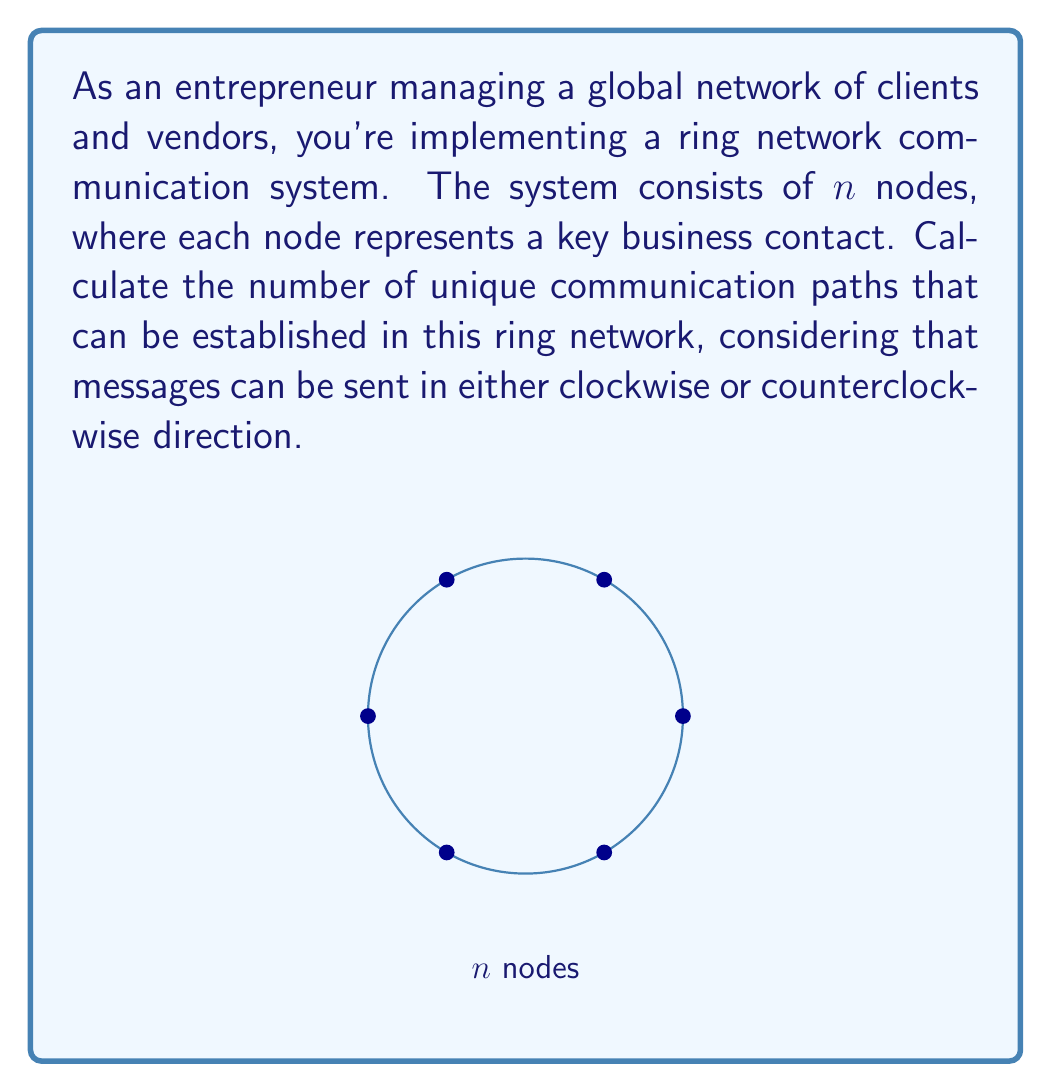Could you help me with this problem? Let's approach this step-by-step:

1) In a ring network with $n$ nodes, each node can communicate with any other node in two ways: clockwise or counterclockwise.

2) For any pair of nodes, there are two unique paths:
   - Clockwise from node A to node B
   - Counterclockwise from node A to node B

3) To count the total number of unique paths, we need to consider all possible pairs of nodes.

4) The total number of pairs in a network with $n$ nodes is given by the combination formula:

   $$\binom{n}{2} = \frac{n!}{2!(n-2)!} = \frac{n(n-1)}{2}$$

5) Since each pair has 2 unique paths (clockwise and counterclockwise), we multiply the number of pairs by 2:

   $$\text{Total unique paths} = 2 \cdot \binom{n}{2} = 2 \cdot \frac{n(n-1)}{2}$$

6) Simplifying:

   $$\text{Total unique paths} = n(n-1)$$

Therefore, in a ring network with $n$ nodes, there are $n(n-1)$ unique communication paths.
Answer: $n(n-1)$ 